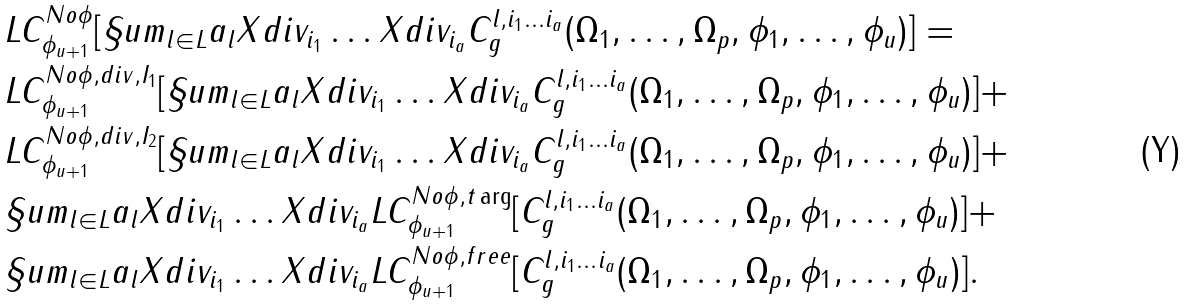<formula> <loc_0><loc_0><loc_500><loc_500>& L C ^ { N o \phi } _ { \phi _ { u + 1 } } [ \S u m _ { l \in L } a _ { l } X d i v _ { i _ { 1 } } \dots X d i v _ { i _ { a } } C ^ { l , i _ { 1 } \dots i _ { a } } _ { g } ( \Omega _ { 1 } , \dots , \Omega _ { p } , \phi _ { 1 } , \dots , \phi _ { u } ) ] = \\ & L C ^ { N o \phi , d i v , I _ { 1 } } _ { \phi _ { u + 1 } } [ \S u m _ { l \in L } a _ { l } X d i v _ { i _ { 1 } } \dots X d i v _ { i _ { a } } C ^ { l , i _ { 1 } \dots i _ { a } } _ { g } ( \Omega _ { 1 } , \dots , \Omega _ { p } , \phi _ { 1 } , \dots , \phi _ { u } ) ] + \\ & L C ^ { N o \phi , d i v , I _ { 2 } } _ { \phi _ { u + 1 } } [ \S u m _ { l \in L } a _ { l } X d i v _ { i _ { 1 } } \dots X d i v _ { i _ { a } } C ^ { l , i _ { 1 } \dots i _ { a } } _ { g } ( \Omega _ { 1 } , \dots , \Omega _ { p } , \phi _ { 1 } , \dots , \phi _ { u } ) ] + \\ & \S u m _ { l \in L } a _ { l } X d i v _ { i _ { 1 } } \dots X d i v _ { i _ { a } } L C ^ { N o \phi , t \arg } _ { \phi _ { u + 1 } } [ C ^ { l , i _ { 1 } \dots i _ { a } } _ { g } ( \Omega _ { 1 } , \dots , \Omega _ { p } , \phi _ { 1 } , \dots , \phi _ { u } ) ] + \\ & \S u m _ { l \in L } a _ { l } X d i v _ { i _ { 1 } } \dots X d i v _ { i _ { a } } L C ^ { N o \phi , f r e e } _ { \phi _ { u + 1 } } [ C ^ { l , i _ { 1 } \dots i _ { a } } _ { g } ( \Omega _ { 1 } , \dots , \Omega _ { p } , \phi _ { 1 } , \dots , \phi _ { u } ) ] .</formula> 